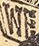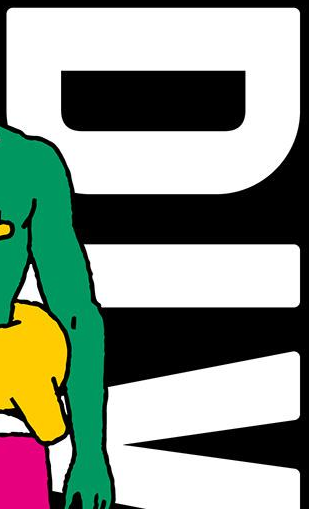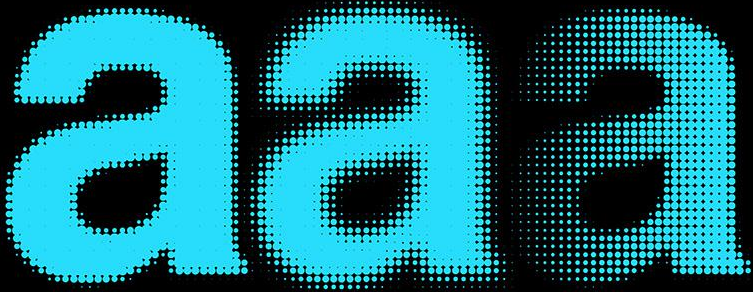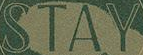Read the text content from these images in order, separated by a semicolon. WE; DIV; aaa; STAY 